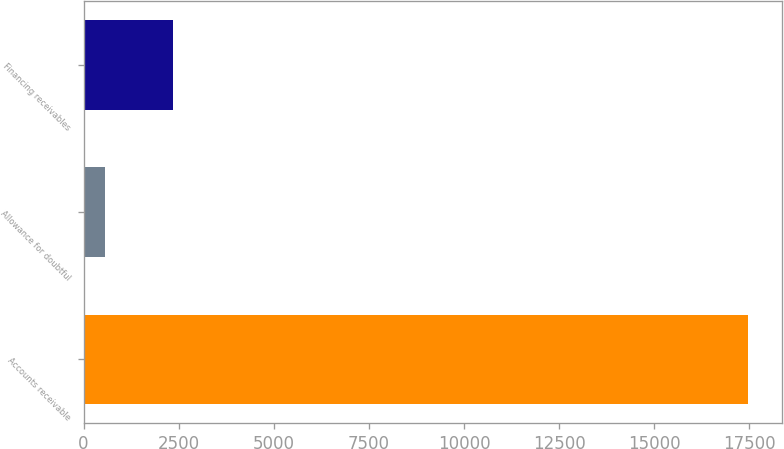<chart> <loc_0><loc_0><loc_500><loc_500><bar_chart><fcel>Accounts receivable<fcel>Allowance for doubtful<fcel>Financing receivables<nl><fcel>17481<fcel>553<fcel>2355<nl></chart> 